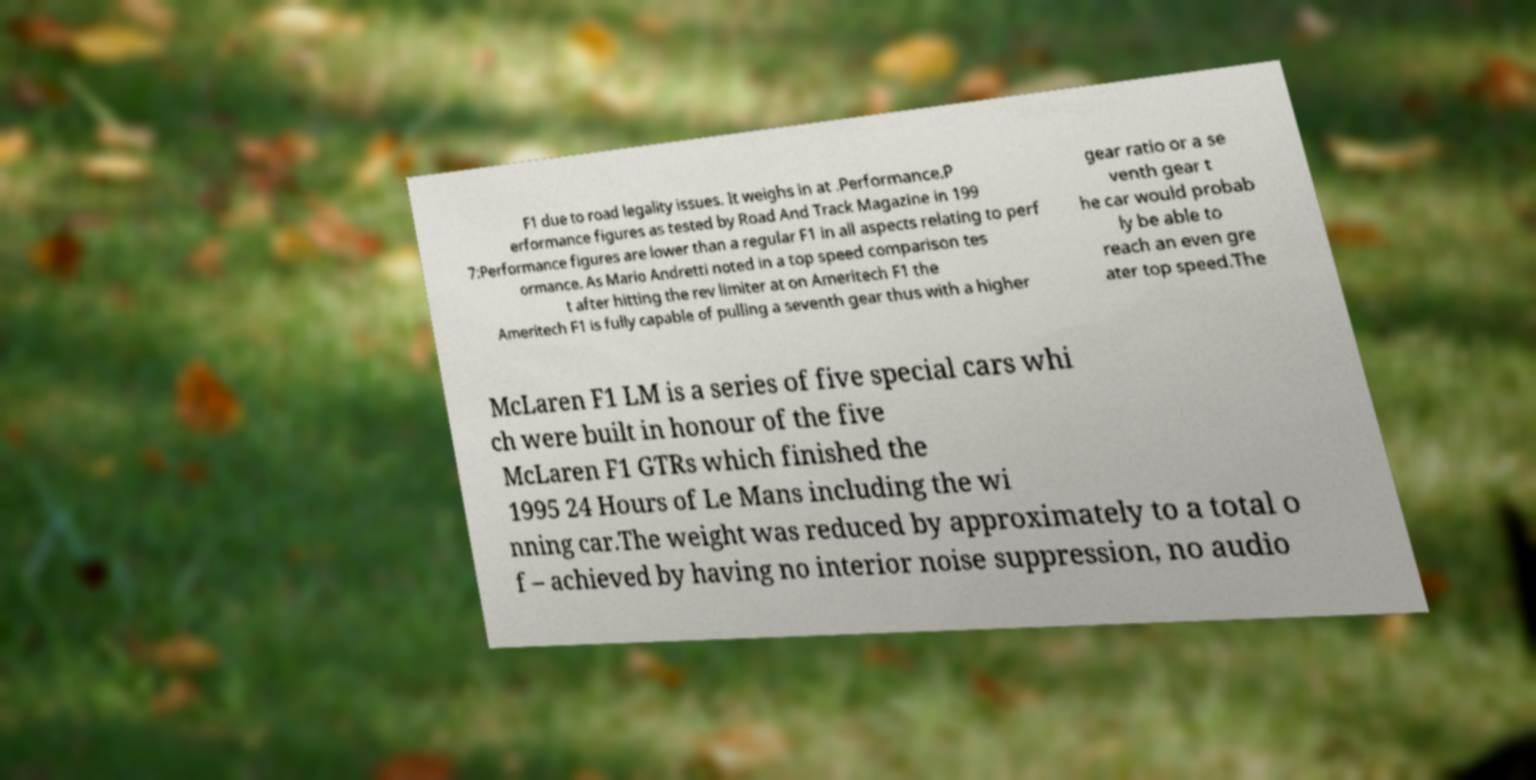For documentation purposes, I need the text within this image transcribed. Could you provide that? F1 due to road legality issues. It weighs in at .Performance.P erformance figures as tested by Road And Track Magazine in 199 7:Performance figures are lower than a regular F1 in all aspects relating to perf ormance. As Mario Andretti noted in a top speed comparison tes t after hitting the rev limiter at on Ameritech F1 the Ameritech F1 is fully capable of pulling a seventh gear thus with a higher gear ratio or a se venth gear t he car would probab ly be able to reach an even gre ater top speed.The McLaren F1 LM is a series of five special cars whi ch were built in honour of the five McLaren F1 GTRs which finished the 1995 24 Hours of Le Mans including the wi nning car.The weight was reduced by approximately to a total o f – achieved by having no interior noise suppression, no audio 